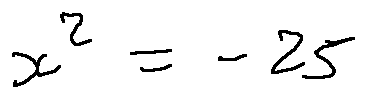<formula> <loc_0><loc_0><loc_500><loc_500>x ^ { 2 } = - 2 5</formula> 